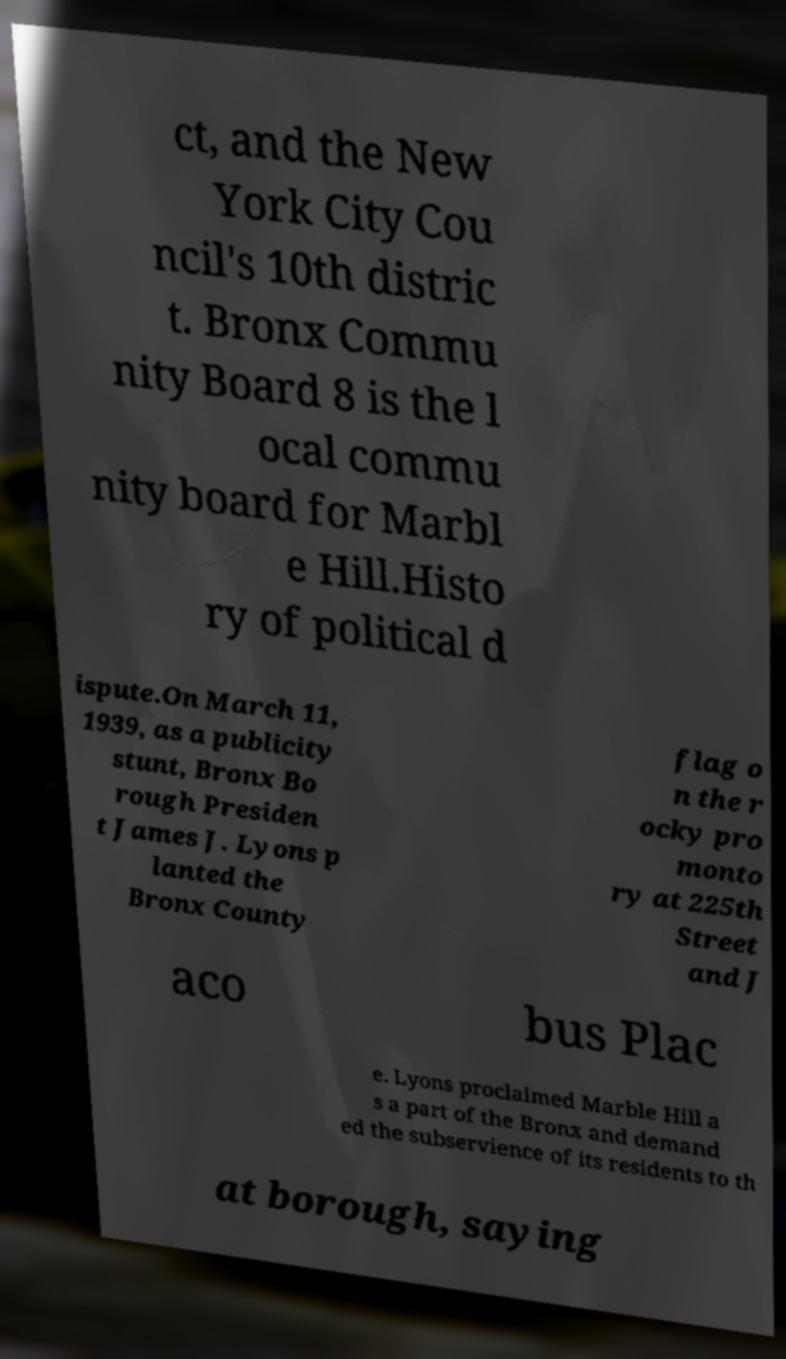Can you accurately transcribe the text from the provided image for me? ct, and the New York City Cou ncil's 10th distric t. Bronx Commu nity Board 8 is the l ocal commu nity board for Marbl e Hill.Histo ry of political d ispute.On March 11, 1939, as a publicity stunt, Bronx Bo rough Presiden t James J. Lyons p lanted the Bronx County flag o n the r ocky pro monto ry at 225th Street and J aco bus Plac e. Lyons proclaimed Marble Hill a s a part of the Bronx and demand ed the subservience of its residents to th at borough, saying 